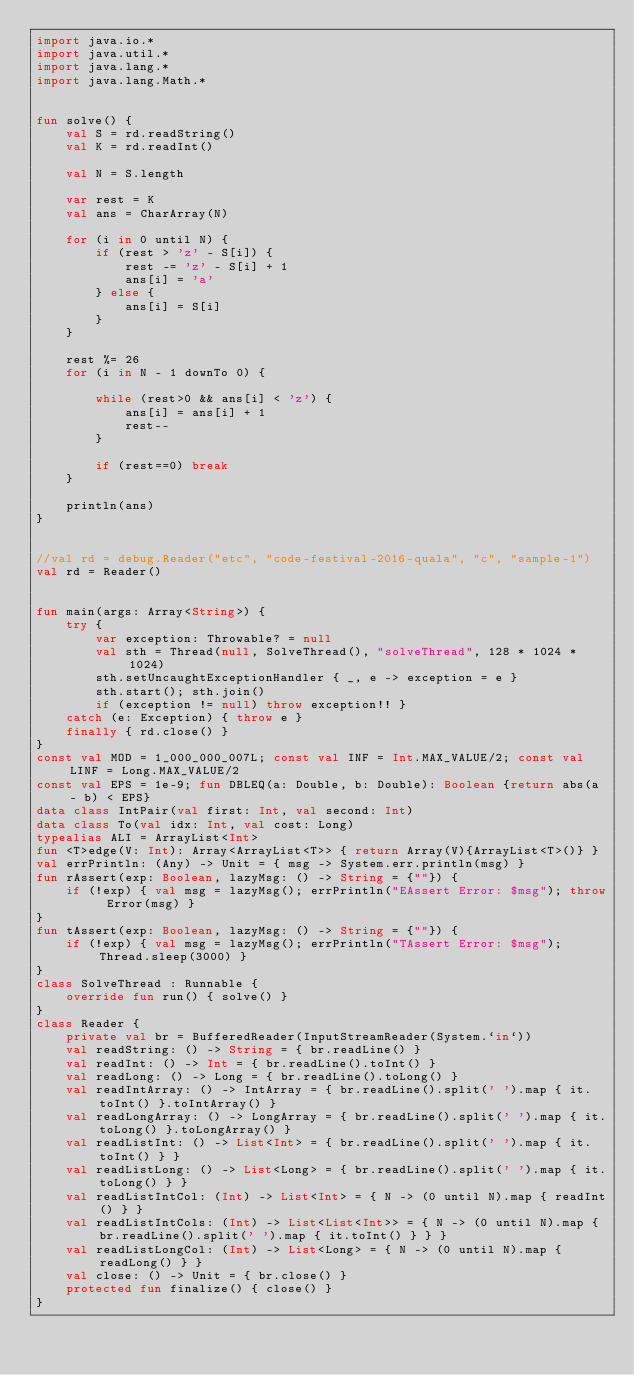<code> <loc_0><loc_0><loc_500><loc_500><_Kotlin_>import java.io.*
import java.util.*
import java.lang.*
import java.lang.Math.*


fun solve() {
    val S = rd.readString()
    val K = rd.readInt()

    val N = S.length

    var rest = K
    val ans = CharArray(N)

    for (i in 0 until N) {
        if (rest > 'z' - S[i]) {
            rest -= 'z' - S[i] + 1
            ans[i] = 'a'
        } else {
            ans[i] = S[i]
        }
    }

    rest %= 26
    for (i in N - 1 downTo 0) {

        while (rest>0 && ans[i] < 'z') {
            ans[i] = ans[i] + 1
            rest--
        }

        if (rest==0) break
    }

    println(ans)
}


//val rd = debug.Reader("etc", "code-festival-2016-quala", "c", "sample-1")
val rd = Reader()


fun main(args: Array<String>) {
    try {
        var exception: Throwable? = null
        val sth = Thread(null, SolveThread(), "solveThread", 128 * 1024 * 1024)
        sth.setUncaughtExceptionHandler { _, e -> exception = e }
        sth.start(); sth.join()
        if (exception != null) throw exception!! }
    catch (e: Exception) { throw e }
    finally { rd.close() }
}
const val MOD = 1_000_000_007L; const val INF = Int.MAX_VALUE/2; const val LINF = Long.MAX_VALUE/2
const val EPS = 1e-9; fun DBLEQ(a: Double, b: Double): Boolean {return abs(a - b) < EPS}
data class IntPair(val first: Int, val second: Int)
data class To(val idx: Int, val cost: Long)
typealias ALI = ArrayList<Int>
fun <T>edge(V: Int): Array<ArrayList<T>> { return Array(V){ArrayList<T>()} }
val errPrintln: (Any) -> Unit = { msg -> System.err.println(msg) }
fun rAssert(exp: Boolean, lazyMsg: () -> String = {""}) {
    if (!exp) { val msg = lazyMsg(); errPrintln("EAssert Error: $msg"); throw Error(msg) }
}
fun tAssert(exp: Boolean, lazyMsg: () -> String = {""}) {
    if (!exp) { val msg = lazyMsg(); errPrintln("TAssert Error: $msg"); Thread.sleep(3000) }
}
class SolveThread : Runnable {
    override fun run() { solve() }
}
class Reader {
    private val br = BufferedReader(InputStreamReader(System.`in`))
    val readString: () -> String = { br.readLine() }
    val readInt: () -> Int = { br.readLine().toInt() }
    val readLong: () -> Long = { br.readLine().toLong() }
    val readIntArray: () -> IntArray = { br.readLine().split(' ').map { it.toInt() }.toIntArray() }
    val readLongArray: () -> LongArray = { br.readLine().split(' ').map { it.toLong() }.toLongArray() }
    val readListInt: () -> List<Int> = { br.readLine().split(' ').map { it.toInt() } }
    val readListLong: () -> List<Long> = { br.readLine().split(' ').map { it.toLong() } }
    val readListIntCol: (Int) -> List<Int> = { N -> (0 until N).map { readInt() } }
    val readListIntCols: (Int) -> List<List<Int>> = { N -> (0 until N).map { br.readLine().split(' ').map { it.toInt() } } }
    val readListLongCol: (Int) -> List<Long> = { N -> (0 until N).map { readLong() } }
    val close: () -> Unit = { br.close() }
    protected fun finalize() { close() }
}
</code> 